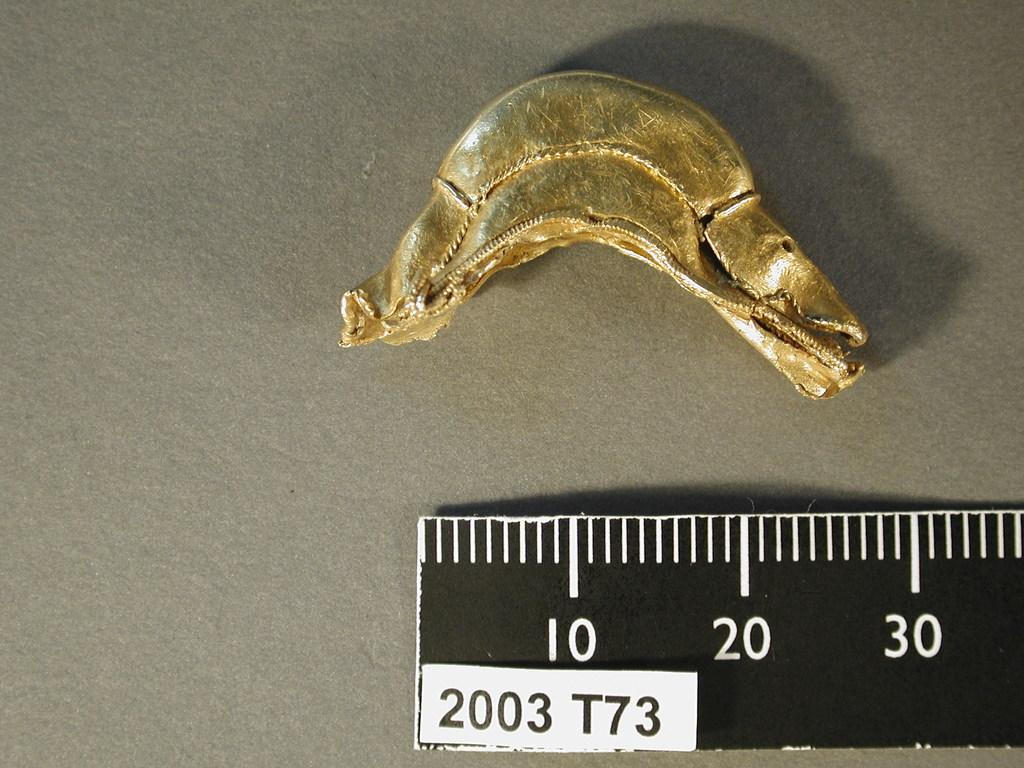<image>
Present a compact description of the photo's key features. A ruler labeled 2003 T73 measures a yellowish item. 